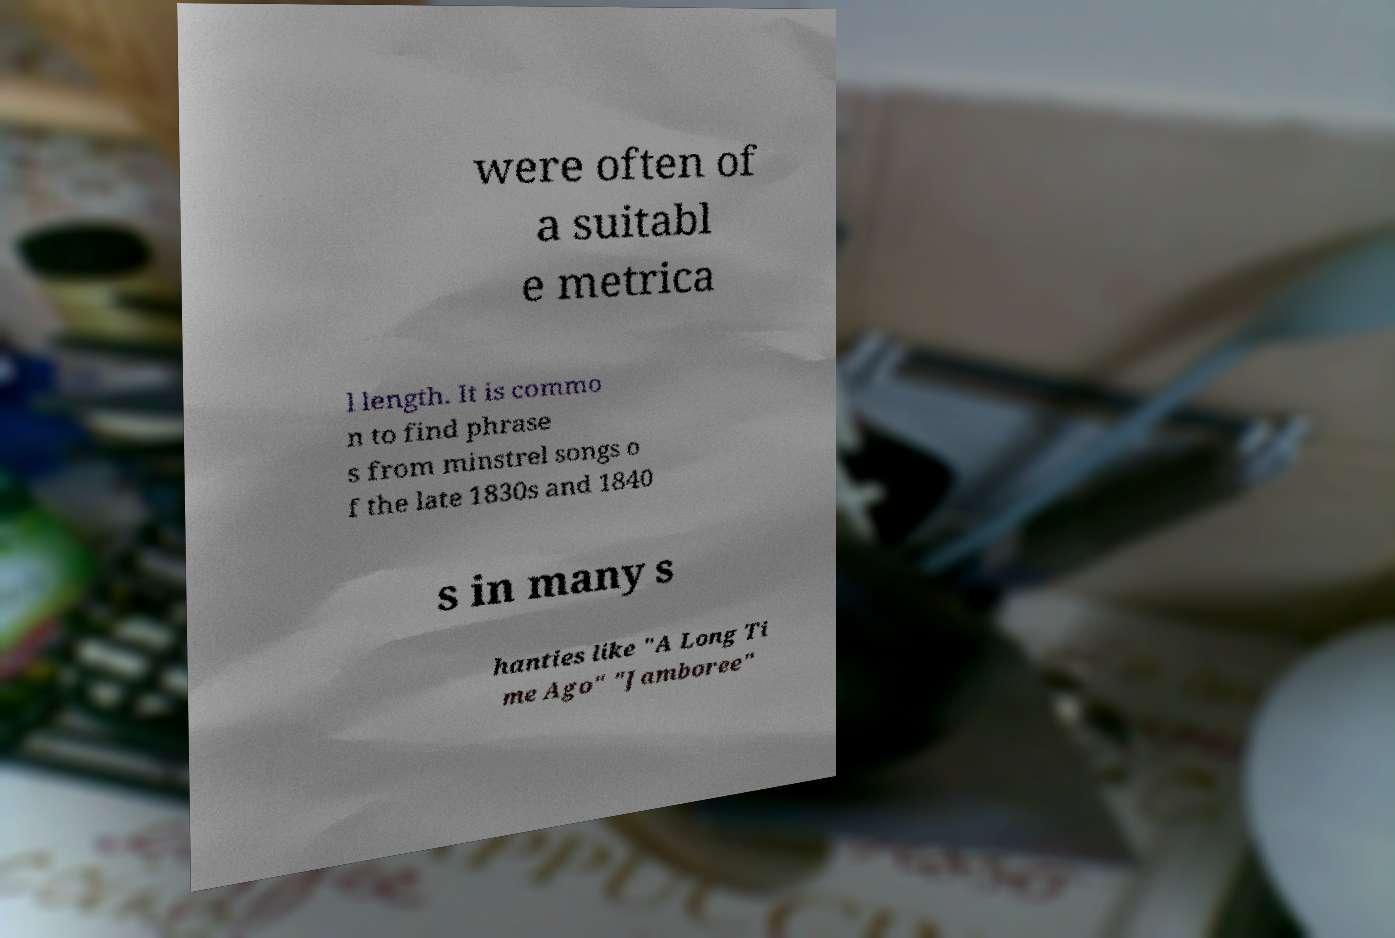Can you read and provide the text displayed in the image?This photo seems to have some interesting text. Can you extract and type it out for me? were often of a suitabl e metrica l length. It is commo n to find phrase s from minstrel songs o f the late 1830s and 1840 s in many s hanties like "A Long Ti me Ago" "Jamboree" 